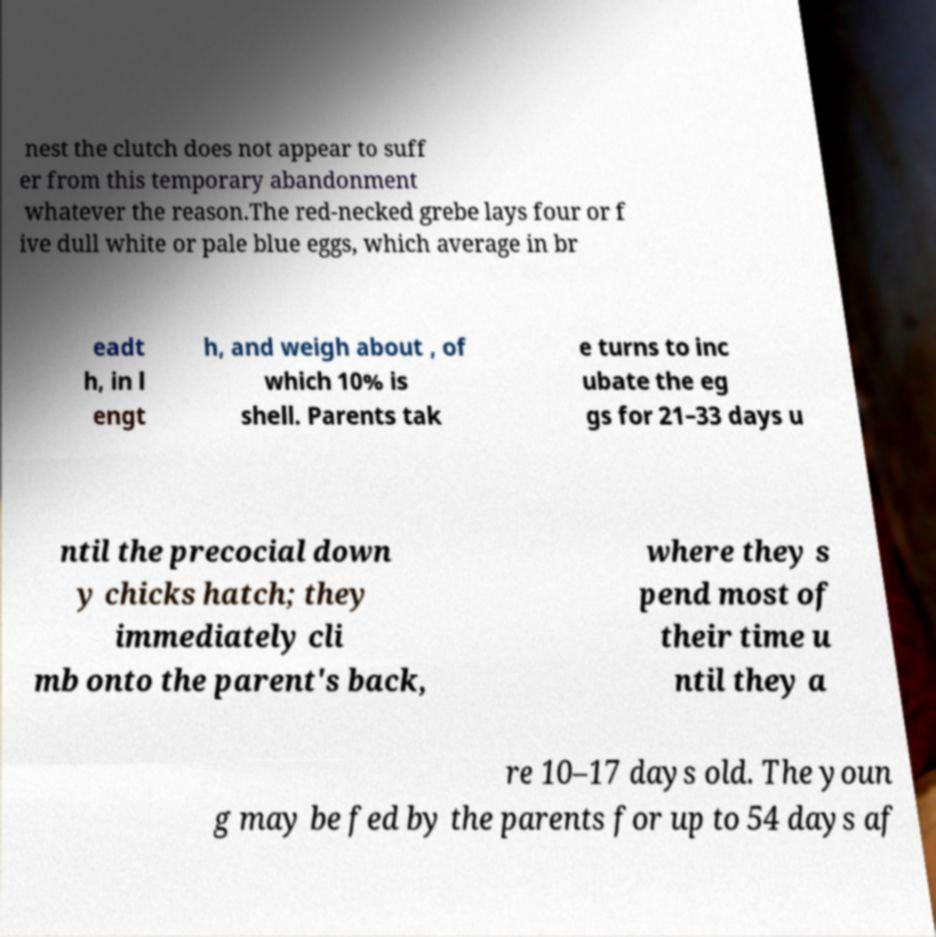Please identify and transcribe the text found in this image. nest the clutch does not appear to suff er from this temporary abandonment whatever the reason.The red-necked grebe lays four or f ive dull white or pale blue eggs, which average in br eadt h, in l engt h, and weigh about , of which 10% is shell. Parents tak e turns to inc ubate the eg gs for 21–33 days u ntil the precocial down y chicks hatch; they immediately cli mb onto the parent's back, where they s pend most of their time u ntil they a re 10–17 days old. The youn g may be fed by the parents for up to 54 days af 